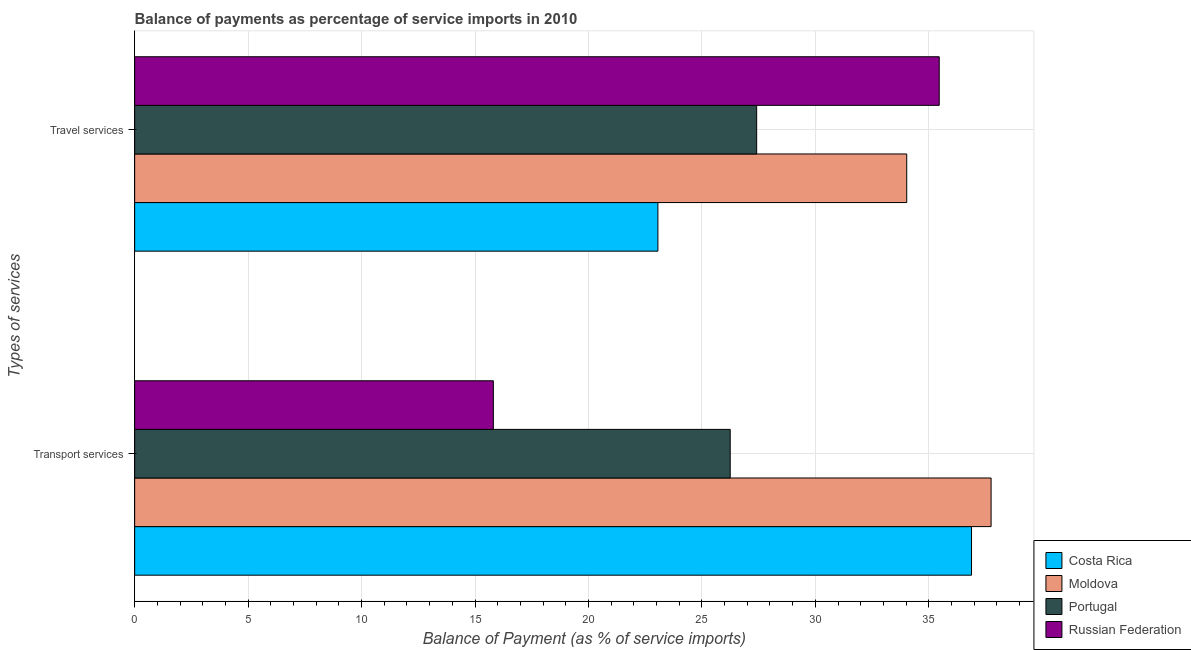How many bars are there on the 2nd tick from the bottom?
Ensure brevity in your answer.  4. What is the label of the 2nd group of bars from the top?
Give a very brief answer. Transport services. What is the balance of payments of transport services in Russian Federation?
Ensure brevity in your answer.  15.81. Across all countries, what is the maximum balance of payments of transport services?
Ensure brevity in your answer.  37.74. Across all countries, what is the minimum balance of payments of transport services?
Offer a terse response. 15.81. In which country was the balance of payments of travel services maximum?
Offer a very short reply. Russian Federation. In which country was the balance of payments of travel services minimum?
Provide a succinct answer. Costa Rica. What is the total balance of payments of transport services in the graph?
Provide a short and direct response. 116.68. What is the difference between the balance of payments of travel services in Portugal and that in Russian Federation?
Your answer should be very brief. -8.05. What is the difference between the balance of payments of transport services in Moldova and the balance of payments of travel services in Portugal?
Give a very brief answer. 10.33. What is the average balance of payments of travel services per country?
Provide a short and direct response. 29.99. What is the difference between the balance of payments of transport services and balance of payments of travel services in Moldova?
Make the answer very short. 3.72. What is the ratio of the balance of payments of travel services in Moldova to that in Russian Federation?
Your answer should be very brief. 0.96. Is the balance of payments of transport services in Portugal less than that in Moldova?
Your answer should be very brief. Yes. What does the 2nd bar from the bottom in Travel services represents?
Provide a short and direct response. Moldova. Does the graph contain any zero values?
Provide a succinct answer. No. Where does the legend appear in the graph?
Your response must be concise. Bottom right. How many legend labels are there?
Make the answer very short. 4. What is the title of the graph?
Ensure brevity in your answer.  Balance of payments as percentage of service imports in 2010. What is the label or title of the X-axis?
Provide a short and direct response. Balance of Payment (as % of service imports). What is the label or title of the Y-axis?
Offer a very short reply. Types of services. What is the Balance of Payment (as % of service imports) of Costa Rica in Transport services?
Offer a very short reply. 36.88. What is the Balance of Payment (as % of service imports) of Moldova in Transport services?
Provide a succinct answer. 37.74. What is the Balance of Payment (as % of service imports) of Portugal in Transport services?
Provide a short and direct response. 26.25. What is the Balance of Payment (as % of service imports) in Russian Federation in Transport services?
Provide a succinct answer. 15.81. What is the Balance of Payment (as % of service imports) of Costa Rica in Travel services?
Your response must be concise. 23.06. What is the Balance of Payment (as % of service imports) of Moldova in Travel services?
Your answer should be very brief. 34.03. What is the Balance of Payment (as % of service imports) in Portugal in Travel services?
Your answer should be very brief. 27.41. What is the Balance of Payment (as % of service imports) in Russian Federation in Travel services?
Your answer should be compact. 35.46. Across all Types of services, what is the maximum Balance of Payment (as % of service imports) of Costa Rica?
Offer a terse response. 36.88. Across all Types of services, what is the maximum Balance of Payment (as % of service imports) of Moldova?
Make the answer very short. 37.74. Across all Types of services, what is the maximum Balance of Payment (as % of service imports) in Portugal?
Your response must be concise. 27.41. Across all Types of services, what is the maximum Balance of Payment (as % of service imports) of Russian Federation?
Provide a short and direct response. 35.46. Across all Types of services, what is the minimum Balance of Payment (as % of service imports) in Costa Rica?
Your response must be concise. 23.06. Across all Types of services, what is the minimum Balance of Payment (as % of service imports) in Moldova?
Provide a short and direct response. 34.03. Across all Types of services, what is the minimum Balance of Payment (as % of service imports) of Portugal?
Give a very brief answer. 26.25. Across all Types of services, what is the minimum Balance of Payment (as % of service imports) in Russian Federation?
Offer a terse response. 15.81. What is the total Balance of Payment (as % of service imports) of Costa Rica in the graph?
Ensure brevity in your answer.  59.94. What is the total Balance of Payment (as % of service imports) of Moldova in the graph?
Keep it short and to the point. 71.77. What is the total Balance of Payment (as % of service imports) of Portugal in the graph?
Your answer should be compact. 53.66. What is the total Balance of Payment (as % of service imports) of Russian Federation in the graph?
Your answer should be compact. 51.27. What is the difference between the Balance of Payment (as % of service imports) of Costa Rica in Transport services and that in Travel services?
Make the answer very short. 13.82. What is the difference between the Balance of Payment (as % of service imports) of Moldova in Transport services and that in Travel services?
Give a very brief answer. 3.72. What is the difference between the Balance of Payment (as % of service imports) in Portugal in Transport services and that in Travel services?
Your response must be concise. -1.17. What is the difference between the Balance of Payment (as % of service imports) in Russian Federation in Transport services and that in Travel services?
Offer a terse response. -19.65. What is the difference between the Balance of Payment (as % of service imports) of Costa Rica in Transport services and the Balance of Payment (as % of service imports) of Moldova in Travel services?
Offer a very short reply. 2.86. What is the difference between the Balance of Payment (as % of service imports) of Costa Rica in Transport services and the Balance of Payment (as % of service imports) of Portugal in Travel services?
Provide a short and direct response. 9.47. What is the difference between the Balance of Payment (as % of service imports) in Costa Rica in Transport services and the Balance of Payment (as % of service imports) in Russian Federation in Travel services?
Give a very brief answer. 1.42. What is the difference between the Balance of Payment (as % of service imports) of Moldova in Transport services and the Balance of Payment (as % of service imports) of Portugal in Travel services?
Provide a succinct answer. 10.33. What is the difference between the Balance of Payment (as % of service imports) in Moldova in Transport services and the Balance of Payment (as % of service imports) in Russian Federation in Travel services?
Your response must be concise. 2.29. What is the difference between the Balance of Payment (as % of service imports) in Portugal in Transport services and the Balance of Payment (as % of service imports) in Russian Federation in Travel services?
Offer a very short reply. -9.21. What is the average Balance of Payment (as % of service imports) of Costa Rica per Types of services?
Provide a short and direct response. 29.97. What is the average Balance of Payment (as % of service imports) in Moldova per Types of services?
Give a very brief answer. 35.88. What is the average Balance of Payment (as % of service imports) of Portugal per Types of services?
Ensure brevity in your answer.  26.83. What is the average Balance of Payment (as % of service imports) in Russian Federation per Types of services?
Keep it short and to the point. 25.63. What is the difference between the Balance of Payment (as % of service imports) of Costa Rica and Balance of Payment (as % of service imports) of Moldova in Transport services?
Keep it short and to the point. -0.86. What is the difference between the Balance of Payment (as % of service imports) of Costa Rica and Balance of Payment (as % of service imports) of Portugal in Transport services?
Provide a succinct answer. 10.63. What is the difference between the Balance of Payment (as % of service imports) of Costa Rica and Balance of Payment (as % of service imports) of Russian Federation in Transport services?
Give a very brief answer. 21.07. What is the difference between the Balance of Payment (as % of service imports) in Moldova and Balance of Payment (as % of service imports) in Portugal in Transport services?
Make the answer very short. 11.5. What is the difference between the Balance of Payment (as % of service imports) of Moldova and Balance of Payment (as % of service imports) of Russian Federation in Transport services?
Your answer should be very brief. 21.94. What is the difference between the Balance of Payment (as % of service imports) in Portugal and Balance of Payment (as % of service imports) in Russian Federation in Transport services?
Your answer should be compact. 10.44. What is the difference between the Balance of Payment (as % of service imports) in Costa Rica and Balance of Payment (as % of service imports) in Moldova in Travel services?
Provide a succinct answer. -10.96. What is the difference between the Balance of Payment (as % of service imports) of Costa Rica and Balance of Payment (as % of service imports) of Portugal in Travel services?
Provide a short and direct response. -4.35. What is the difference between the Balance of Payment (as % of service imports) of Costa Rica and Balance of Payment (as % of service imports) of Russian Federation in Travel services?
Provide a succinct answer. -12.4. What is the difference between the Balance of Payment (as % of service imports) of Moldova and Balance of Payment (as % of service imports) of Portugal in Travel services?
Your response must be concise. 6.61. What is the difference between the Balance of Payment (as % of service imports) of Moldova and Balance of Payment (as % of service imports) of Russian Federation in Travel services?
Your answer should be compact. -1.43. What is the difference between the Balance of Payment (as % of service imports) of Portugal and Balance of Payment (as % of service imports) of Russian Federation in Travel services?
Offer a very short reply. -8.05. What is the ratio of the Balance of Payment (as % of service imports) in Costa Rica in Transport services to that in Travel services?
Make the answer very short. 1.6. What is the ratio of the Balance of Payment (as % of service imports) in Moldova in Transport services to that in Travel services?
Your answer should be very brief. 1.11. What is the ratio of the Balance of Payment (as % of service imports) of Portugal in Transport services to that in Travel services?
Offer a terse response. 0.96. What is the ratio of the Balance of Payment (as % of service imports) in Russian Federation in Transport services to that in Travel services?
Offer a very short reply. 0.45. What is the difference between the highest and the second highest Balance of Payment (as % of service imports) in Costa Rica?
Make the answer very short. 13.82. What is the difference between the highest and the second highest Balance of Payment (as % of service imports) of Moldova?
Ensure brevity in your answer.  3.72. What is the difference between the highest and the second highest Balance of Payment (as % of service imports) in Portugal?
Make the answer very short. 1.17. What is the difference between the highest and the second highest Balance of Payment (as % of service imports) of Russian Federation?
Your answer should be compact. 19.65. What is the difference between the highest and the lowest Balance of Payment (as % of service imports) in Costa Rica?
Provide a short and direct response. 13.82. What is the difference between the highest and the lowest Balance of Payment (as % of service imports) in Moldova?
Provide a succinct answer. 3.72. What is the difference between the highest and the lowest Balance of Payment (as % of service imports) in Portugal?
Provide a succinct answer. 1.17. What is the difference between the highest and the lowest Balance of Payment (as % of service imports) of Russian Federation?
Provide a succinct answer. 19.65. 